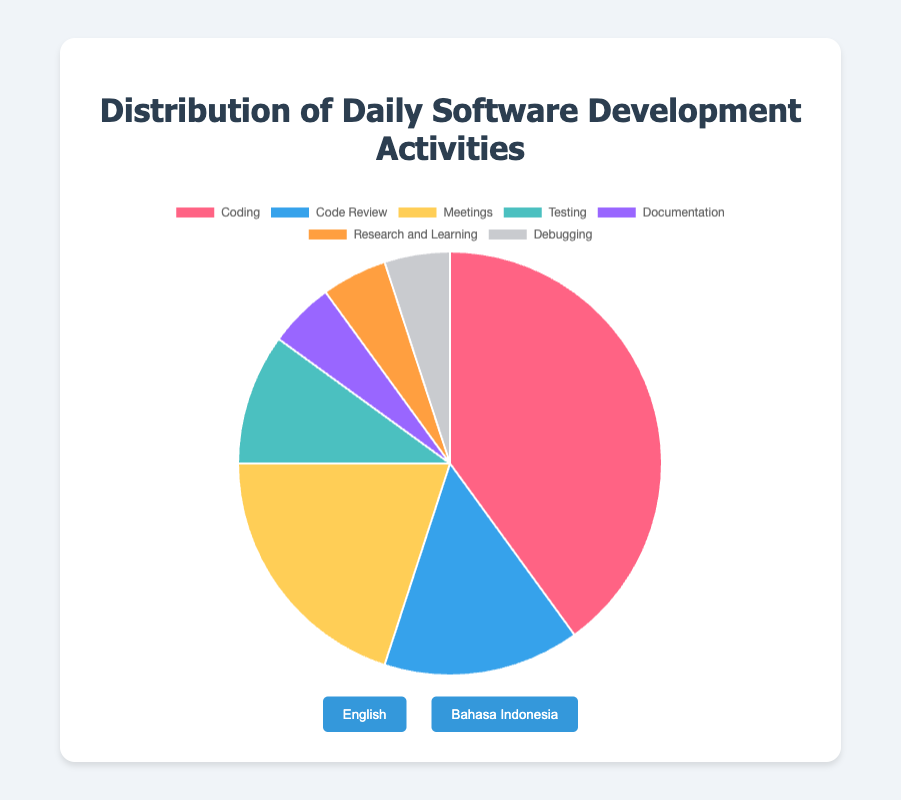Which activity takes up the largest percentage of daily software development activities? Coding takes the largest percentage at 40%. This is determined by finding the activity with the highest percentage value.
Answer: Coding What is the total percentage of time spent on activities other than Coding? Adding the percentages of all activities except Coding gives: 15 (Code Review) + 20 (Meetings) + 10 (Testing) + 5 (Documentation) + 5 (Research and Learning) + 5 (Debugging) = 60%.
Answer: 60% Which activity is represented by the color red in the pie chart? The activity represented by the color red has the highest percentage, which is Coding at 40%. The chart usually uses visually identifiable colors for significant portions.
Answer: Coding How much more time is spent on Meetings compared to Tests? The percentage of time spent on Meetings (20%) minus the percentage of time spent on Testing (10%) is calculated as 20 - 10 = 10%.
Answer: 10% What are the total percentages of time spent on Documentation, Research and Learning, and Debugging? Summing the percentages: 5 (Documentation) + 5 (Research and Learning) + 5 (Debugging) equals 15%.
Answer: 15% What is the average percentage of time spent on Testing, Documentation, and Research and Learning? Adding the percentages: 10 (Testing) + 5 (Documentation) + 5 (Research and Learning) = 20, and dividing by 3 results in 20 / 3 ≈ 6.67%.
Answer: 6.67% Does more time get spent on Code Review or Testing? Comparing the values, we see that Code Review (15%) takes more time than Testing (10%).
Answer: Code Review Which activity takes the least amount of time? Several activities (Documentation, Research and Learning, Debugging) have the lowest percentage, each at 5%.
Answer: Documentation, Research and Learning, Debugging How much more percentage of time is spent on Coding compared to Code Review and Testing combined? First, add the percentages of Code Review and Testing: 15 + 10 = 25%. Then subtract from the percentage of Coding: 40 - 25 = 15%.
Answer: 15% What is the combined percentage of time spent on Meetings and Documentation? Adding the percentages for Meetings and Documentation gives: 20 + 5 = 25%.
Answer: 25% 